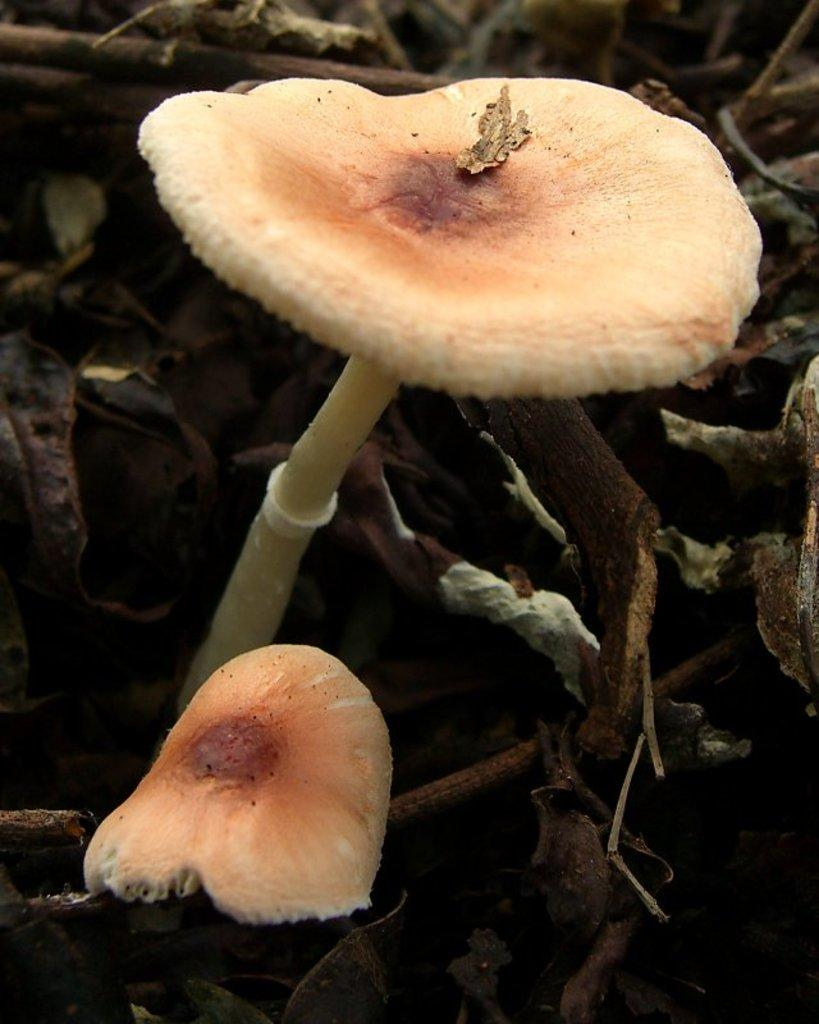How many mushrooms are present in the image? There are two mushrooms in the image. What colors are the mushrooms? The mushrooms are brown and cream in color. What other natural elements can be seen in the image? There are leaves and wooden logs in the image. What type of net is being used to catch the mushrooms in the image? There is no net present in the image, and the mushrooms are not being caught. 